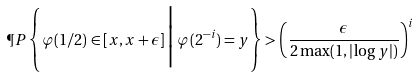Convert formula to latex. <formula><loc_0><loc_0><loc_500><loc_500>\P P \left \{ \varphi ( 1 / 2 ) \in [ x , x + \epsilon ] \, \Big | \, \varphi ( 2 ^ { - i } ) = y \right \} > \left ( \frac { \epsilon } { 2 \max ( 1 , | \log y | ) } \right ) ^ { i }</formula> 